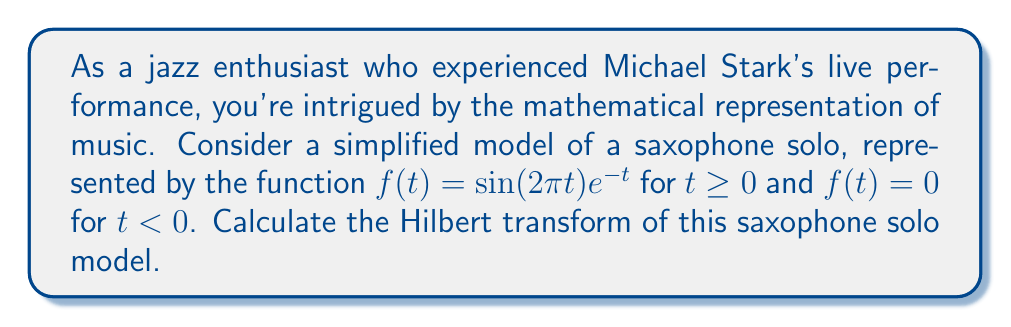Could you help me with this problem? To calculate the Hilbert transform of the given function, we'll follow these steps:

1) The Hilbert transform is defined as:

   $$\mathcal{H}[f](t) = \frac{1}{\pi} \text{P.V.} \int_{-\infty}^{\infty} \frac{f(\tau)}{t-\tau} d\tau$$

   where P.V. denotes the Cauchy principal value.

2) For our function $f(t) = \sin(2\pi t) e^{-t}$ for $t \geq 0$ and $f(t) = 0$ for $t < 0$, we can write:

   $$\mathcal{H}[f](t) = \frac{1}{\pi} \text{P.V.} \int_{0}^{\infty} \frac{\sin(2\pi \tau) e^{-\tau}}{t-\tau} d\tau$$

3) This integral is complex, but we can use a known result for the Hilbert transform of the product of sine and an exponential decay:

   For $f(t) = \sin(\omega t) e^{-at}$ where $a > 0$ and $t \geq 0$,
   
   $$\mathcal{H}[f](t) = -\cos(\omega t) e^{-at} + \frac{2a}{\pi} e^{-at} \int_{0}^{\infty} \frac{e^{-a\tau} \sin(\omega \tau)}{a^2 + (\omega - \tau/t)^2} d\tau$$

4) In our case, $\omega = 2\pi$ and $a = 1$. Substituting these values:

   $$\mathcal{H}[f](t) = -\cos(2\pi t) e^{-t} + \frac{2}{\pi} e^{-t} \int_{0}^{\infty} \frac{e^{-\tau} \sin(2\pi \tau)}{1 + (2\pi - \tau/t)^2} d\tau$$

5) The integral in this expression doesn't have a simple closed form, but it can be evaluated numerically for specific values of $t$.
Answer: The Hilbert transform of the saxophone solo model $f(t) = \sin(2\pi t) e^{-t}$ for $t \geq 0$ and $f(t) = 0$ for $t < 0$ is:

$$\mathcal{H}[f](t) = -\cos(2\pi t) e^{-t} + \frac{2}{\pi} e^{-t} \int_{0}^{\infty} \frac{e^{-\tau} \sin(2\pi \tau)}{1 + (2\pi - \tau/t)^2} d\tau$$

where the integral term needs to be evaluated numerically for specific values of $t$. 